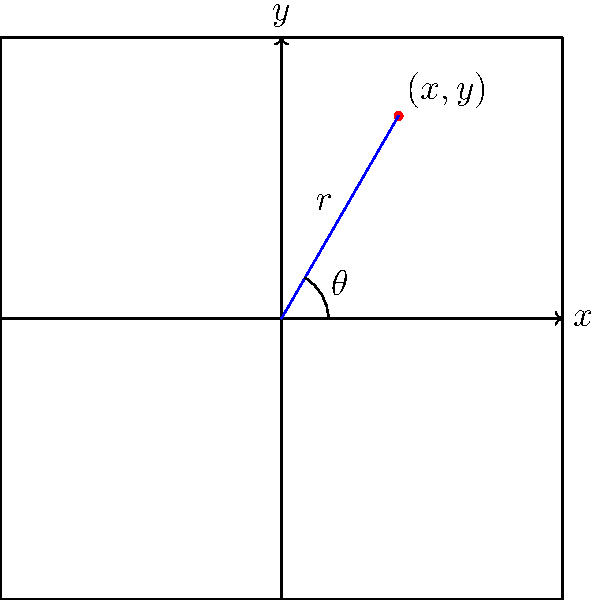Given a point in polar coordinates $(r, \theta)$ where $r = 5$ and $\theta = \frac{\pi}{3}$, convert this point to Cartesian coordinates $(x, y)$ and create an HTML5 canvas element to display the point. Provide the JavaScript code to draw the coordinate axes, the point, and label it on the canvas. To solve this problem, we'll follow these steps:

1. Convert polar coordinates to Cartesian coordinates:
   The formulas for conversion are:
   $x = r \cos(\theta)$
   $y = r \sin(\theta)$

   Substituting the given values:
   $x = 5 \cos(\frac{\pi}{3}) = 5 \cdot \frac{1}{2} = 2.5$
   $y = 5 \sin(\frac{\pi}{3}) = 5 \cdot \frac{\sqrt{3}}{2} \approx 4.33$

2. Create an HTML5 canvas element:
   ```html
   <canvas id="myCanvas" width="400" height="400"></canvas>
   ```

3. Write JavaScript code to draw on the canvas:
   ```javascript
   const canvas = document.getElementById('myCanvas');
   const ctx = canvas.getContext('2d');
   
   // Set canvas origin to center
   ctx.translate(200, 200);
   
   // Draw x and y axes
   ctx.beginPath();
   ctx.moveTo(-200, 0);
   ctx.lineTo(200, 0);
   ctx.moveTo(0, -200);
   ctx.lineTo(0, 200);
   ctx.stroke();
   
   // Draw point
   ctx.beginPath();
   ctx.arc(2.5 * 20, -4.33 * 20, 5, 0, 2 * Math.PI);
   ctx.fillStyle = 'red';
   ctx.fill();
   
   // Label point
   ctx.fillStyle = 'black';
   ctx.font = '12px Arial';
   ctx.fillText('(2.5, 4.33)', 2.5 * 20 + 10, -4.33 * 20 - 10);
   ```

   Note: We multiply the coordinates by 20 to scale them up for better visibility on the canvas.

4. Combine the HTML and JavaScript:
   ```html
   <!DOCTYPE html>
   <html>
   <body>
     <canvas id="myCanvas" width="400" height="400"></canvas>
     <script>
       // JavaScript code from step 3 goes here
     </script>
   </body>
   </html>
   ```

This solution converts the polar coordinates to Cartesian coordinates and then uses HTML5 canvas to visually represent the point in a coordinate system.
Answer: $(2.5, 4.33)$; HTML5 canvas with JavaScript to draw axes, point, and label. 